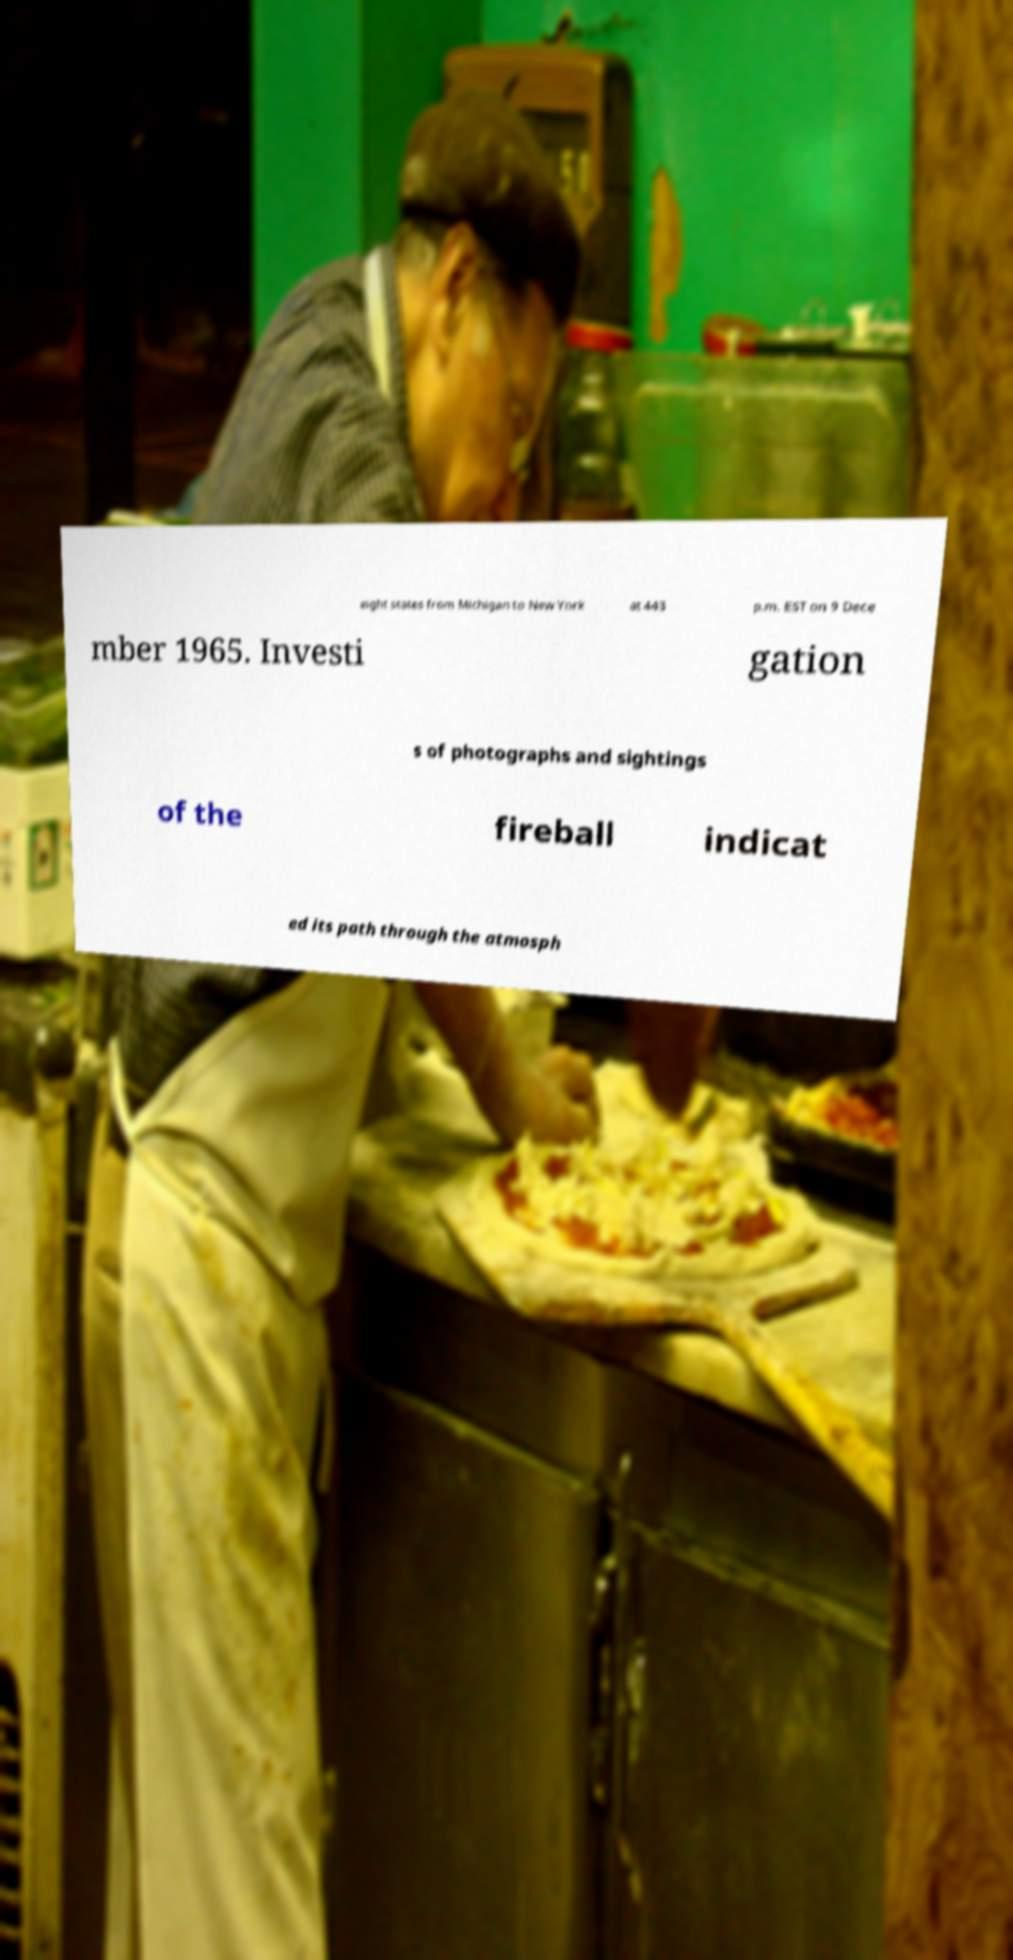I need the written content from this picture converted into text. Can you do that? eight states from Michigan to New York at 443 p.m. EST on 9 Dece mber 1965. Investi gation s of photographs and sightings of the fireball indicat ed its path through the atmosph 